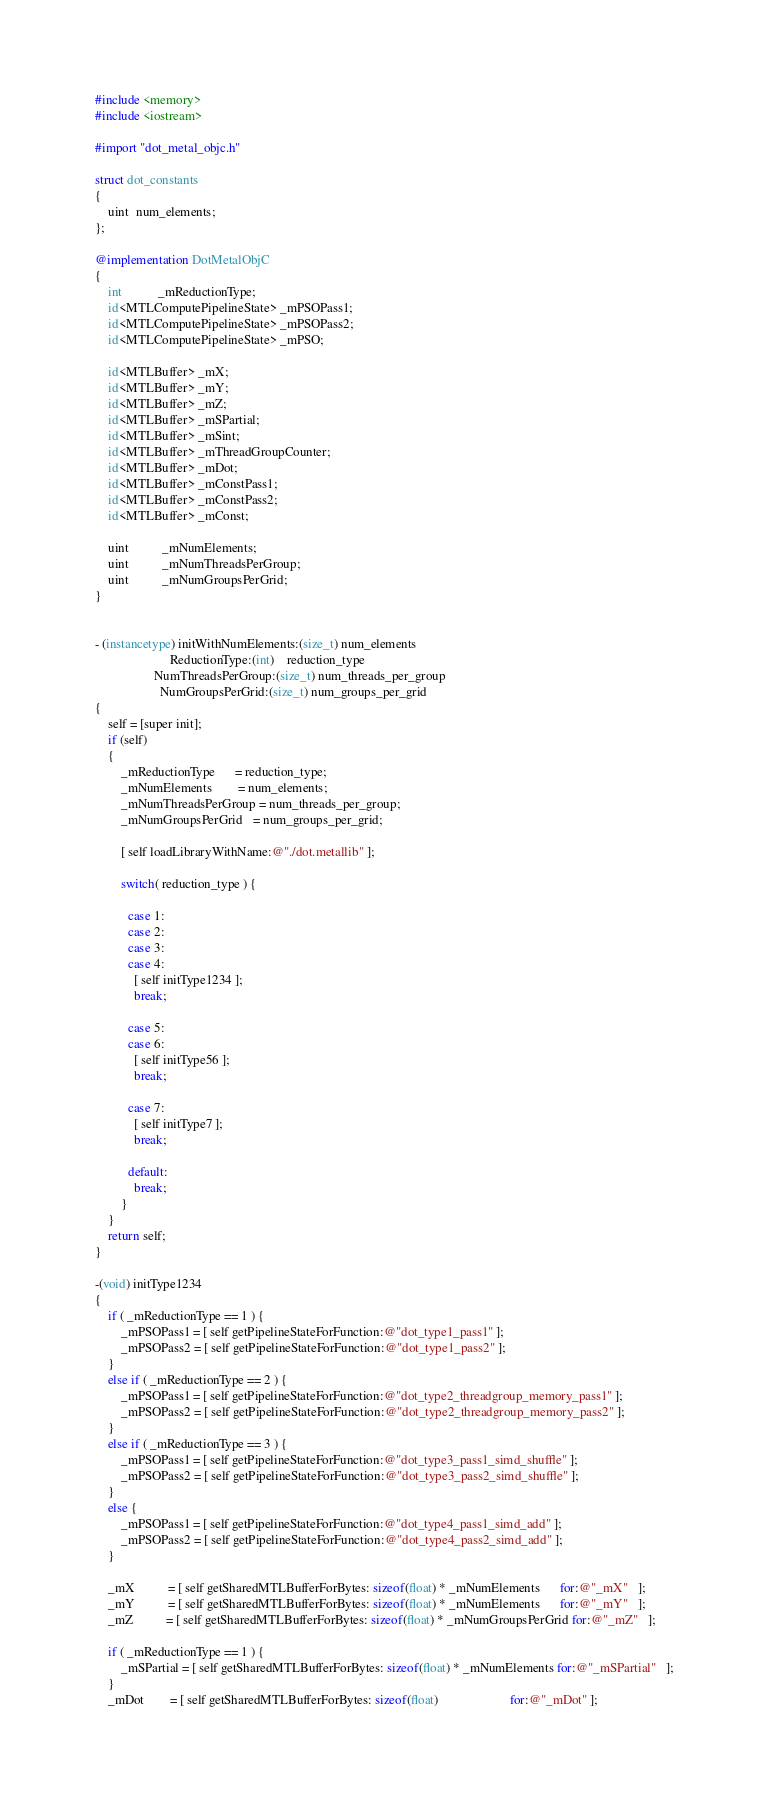<code> <loc_0><loc_0><loc_500><loc_500><_ObjectiveC_>#include <memory>
#include <iostream>

#import "dot_metal_objc.h"

struct dot_constants
{
    uint  num_elements;
};

@implementation DotMetalObjC
{
    int           _mReductionType;
    id<MTLComputePipelineState> _mPSOPass1;
    id<MTLComputePipelineState> _mPSOPass2;
    id<MTLComputePipelineState> _mPSO;

    id<MTLBuffer> _mX;
    id<MTLBuffer> _mY;
    id<MTLBuffer> _mZ;
    id<MTLBuffer> _mSPartial;
    id<MTLBuffer> _mSint;
    id<MTLBuffer> _mThreadGroupCounter;
    id<MTLBuffer> _mDot;
    id<MTLBuffer> _mConstPass1;
    id<MTLBuffer> _mConstPass2;
    id<MTLBuffer> _mConst;

    uint          _mNumElements;
    uint          _mNumThreadsPerGroup;
    uint          _mNumGroupsPerGrid;
}


- (instancetype) initWithNumElements:(size_t) num_elements 
                       ReductionType:(int)    reduction_type
                  NumThreadsPerGroup:(size_t) num_threads_per_group
                    NumGroupsPerGrid:(size_t) num_groups_per_grid
{
    self = [super init];
    if (self)
    {
        _mReductionType      = reduction_type;
        _mNumElements        = num_elements;
        _mNumThreadsPerGroup = num_threads_per_group;
        _mNumGroupsPerGrid   = num_groups_per_grid;

        [ self loadLibraryWithName:@"./dot.metallib" ];

        switch( reduction_type ) {

          case 1:
          case 2:
          case 3:
          case 4:
            [ self initType1234 ];
            break;

          case 5:
          case 6:
            [ self initType56 ];
            break;

          case 7:
            [ self initType7 ];
            break;

          default:
            break;
        }
    }
    return self;
}

-(void) initType1234
{
    if ( _mReductionType == 1 ) {
        _mPSOPass1 = [ self getPipelineStateForFunction:@"dot_type1_pass1" ];
        _mPSOPass2 = [ self getPipelineStateForFunction:@"dot_type1_pass2" ];
    }
    else if ( _mReductionType == 2 ) {
        _mPSOPass1 = [ self getPipelineStateForFunction:@"dot_type2_threadgroup_memory_pass1" ];
        _mPSOPass2 = [ self getPipelineStateForFunction:@"dot_type2_threadgroup_memory_pass2" ];
    }
    else if ( _mReductionType == 3 ) {
        _mPSOPass1 = [ self getPipelineStateForFunction:@"dot_type3_pass1_simd_shuffle" ];
        _mPSOPass2 = [ self getPipelineStateForFunction:@"dot_type3_pass2_simd_shuffle" ];
    }
    else {
        _mPSOPass1 = [ self getPipelineStateForFunction:@"dot_type4_pass1_simd_add" ];
        _mPSOPass2 = [ self getPipelineStateForFunction:@"dot_type4_pass2_simd_add" ];
    }

    _mX          = [ self getSharedMTLBufferForBytes: sizeof(float) * _mNumElements      for:@"_mX"   ];
    _mY          = [ self getSharedMTLBufferForBytes: sizeof(float) * _mNumElements      for:@"_mY"   ];
    _mZ          = [ self getSharedMTLBufferForBytes: sizeof(float) * _mNumGroupsPerGrid for:@"_mZ"   ];

    if ( _mReductionType == 1 ) {
        _mSPartial = [ self getSharedMTLBufferForBytes: sizeof(float) * _mNumElements for:@"_mSPartial"   ];
    }
    _mDot        = [ self getSharedMTLBufferForBytes: sizeof(float)                      for:@"_mDot" ];</code> 